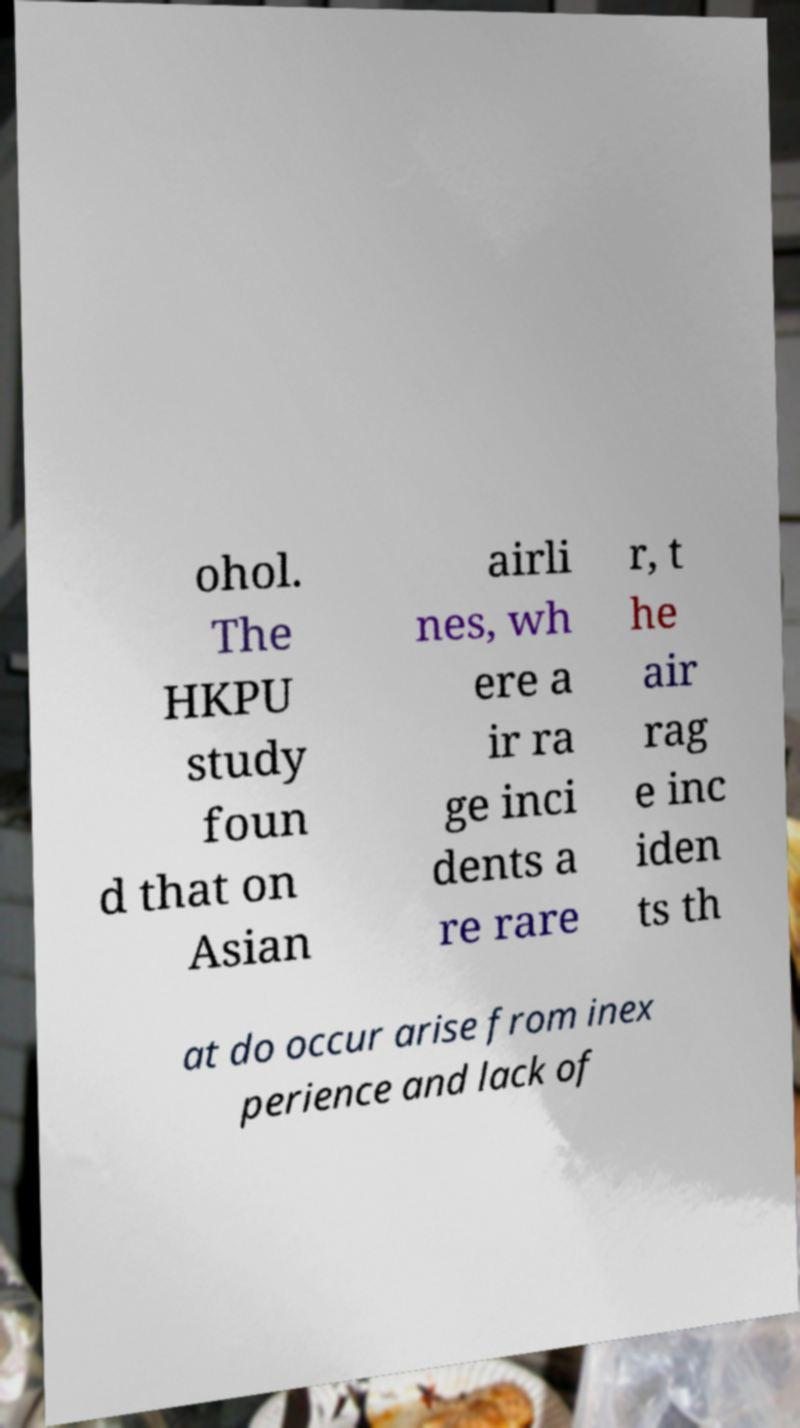Could you assist in decoding the text presented in this image and type it out clearly? ohol. The HKPU study foun d that on Asian airli nes, wh ere a ir ra ge inci dents a re rare r, t he air rag e inc iden ts th at do occur arise from inex perience and lack of 